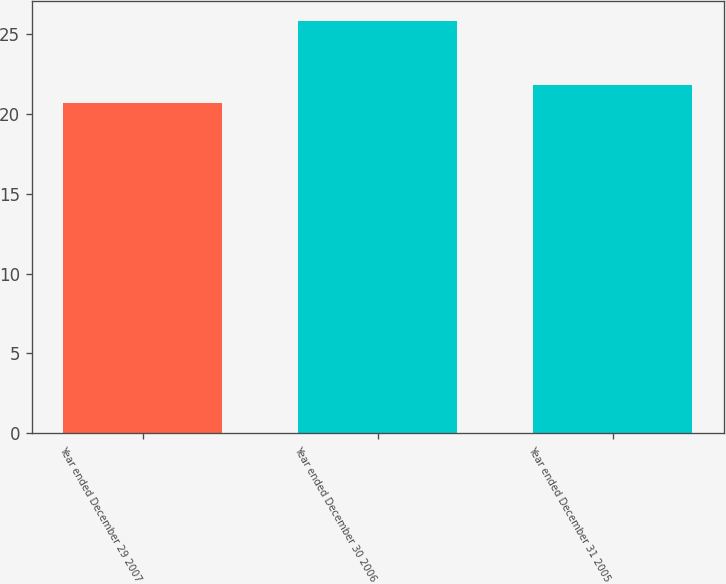<chart> <loc_0><loc_0><loc_500><loc_500><bar_chart><fcel>Year ended December 29 2007<fcel>Year ended December 30 2006<fcel>Year ended December 31 2005<nl><fcel>20.7<fcel>25.8<fcel>21.8<nl></chart> 